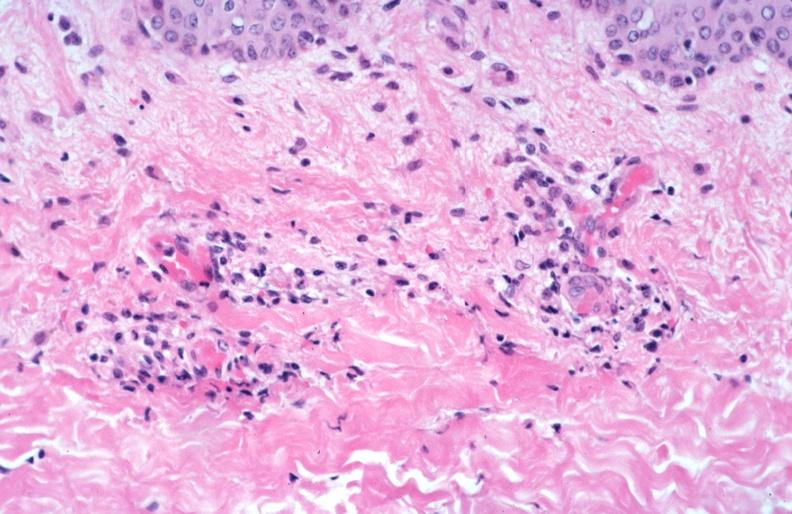does this image show skin?
Answer the question using a single word or phrase. Yes 